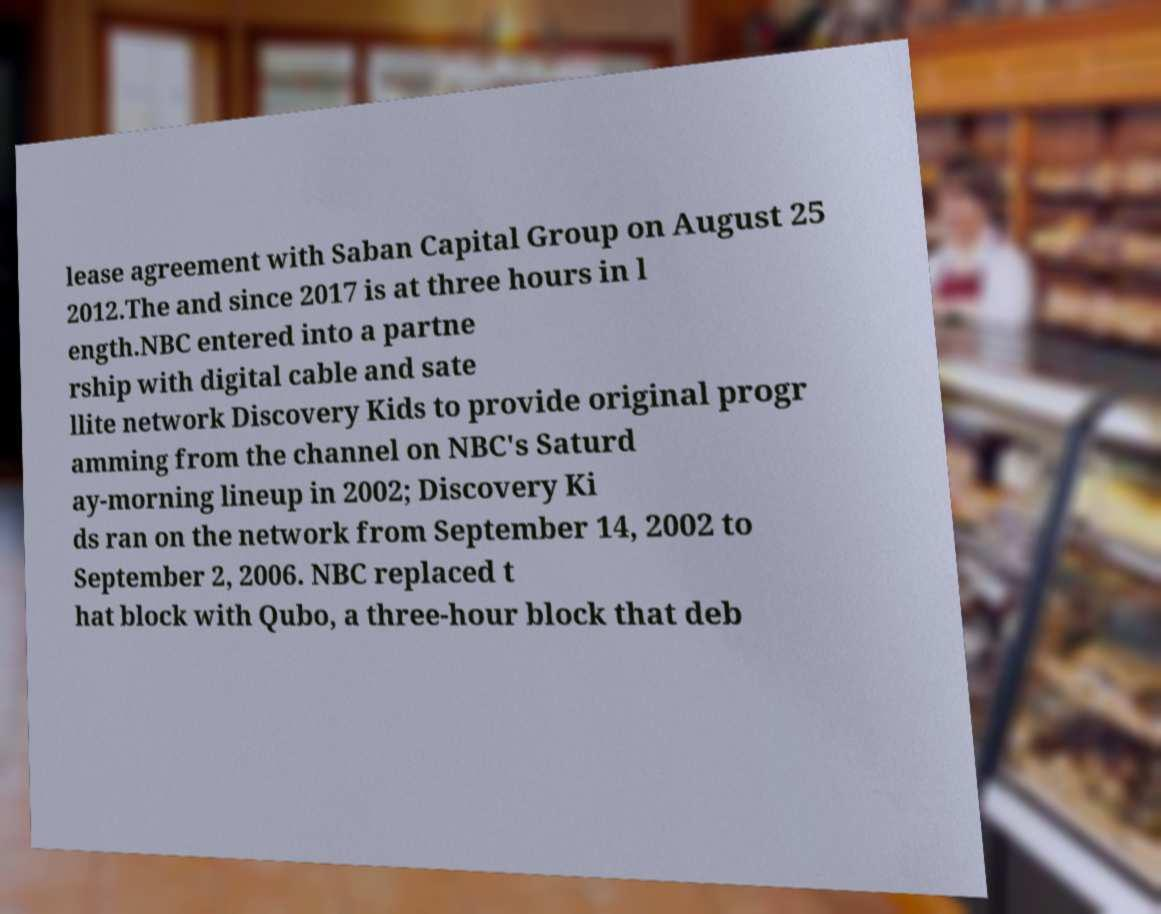Can you accurately transcribe the text from the provided image for me? lease agreement with Saban Capital Group on August 25 2012.The and since 2017 is at three hours in l ength.NBC entered into a partne rship with digital cable and sate llite network Discovery Kids to provide original progr amming from the channel on NBC's Saturd ay-morning lineup in 2002; Discovery Ki ds ran on the network from September 14, 2002 to September 2, 2006. NBC replaced t hat block with Qubo, a three-hour block that deb 